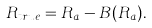Convert formula to latex. <formula><loc_0><loc_0><loc_500><loc_500>R _ { t r u e } = R _ { a } - B ( R _ { a } ) .</formula> 